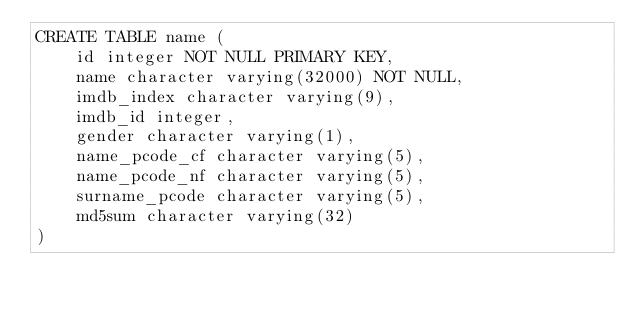<code> <loc_0><loc_0><loc_500><loc_500><_SQL_>CREATE TABLE name (
    id integer NOT NULL PRIMARY KEY,
    name character varying(32000) NOT NULL,
    imdb_index character varying(9),
    imdb_id integer,
    gender character varying(1),
    name_pcode_cf character varying(5),
    name_pcode_nf character varying(5),
    surname_pcode character varying(5),
    md5sum character varying(32)
)</code> 